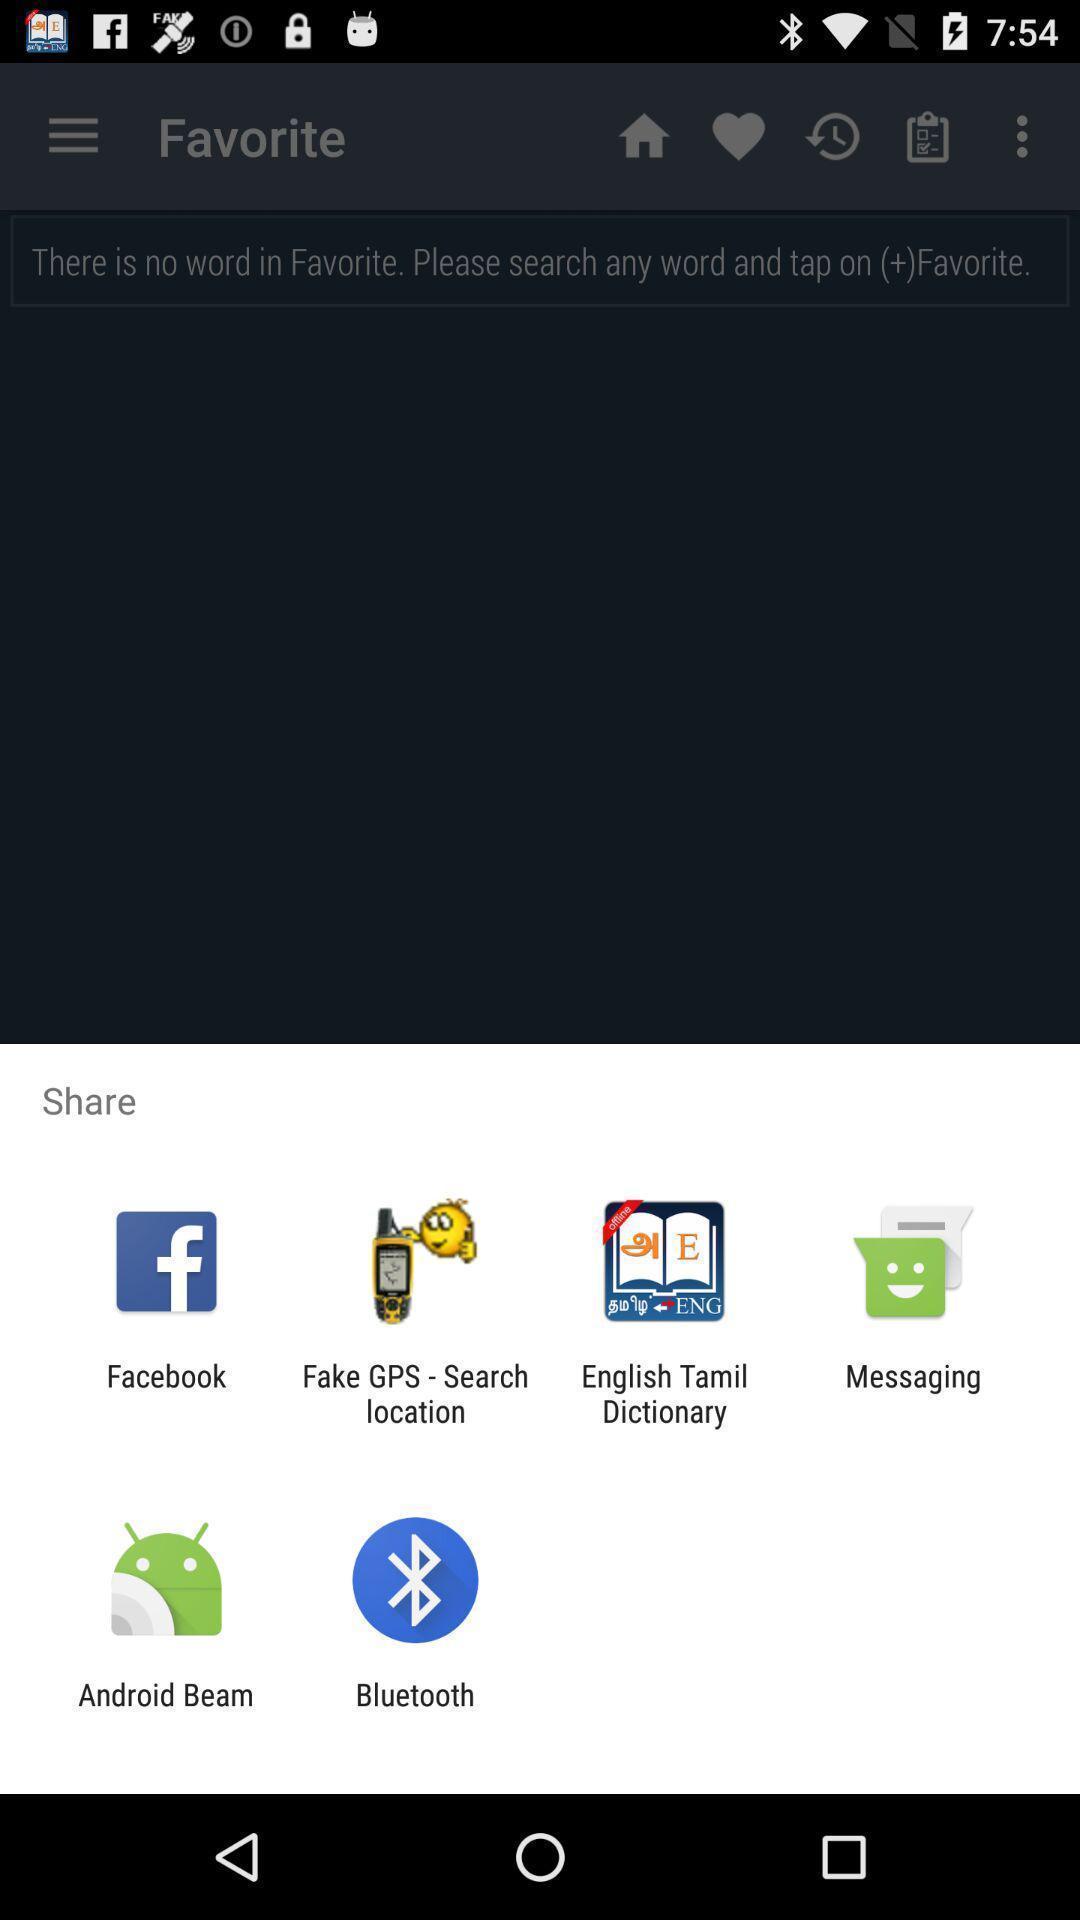Describe the key features of this screenshot. Pop-up showing the various app sharing options. 